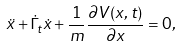<formula> <loc_0><loc_0><loc_500><loc_500>\ddot { x } + \dot { \Gamma } _ { t } \dot { x } + \frac { 1 } { m } \frac { \partial V ( x , t ) } { \partial x } = 0 ,</formula> 